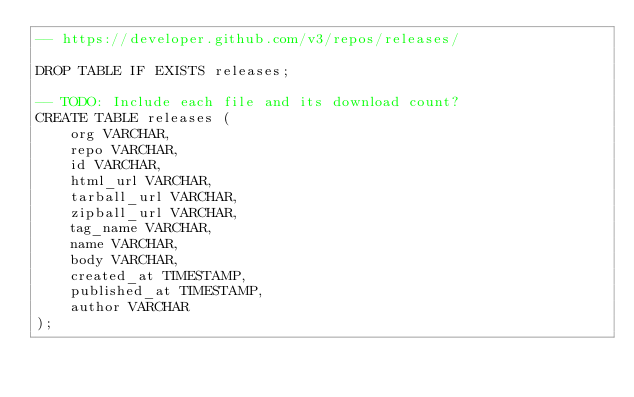Convert code to text. <code><loc_0><loc_0><loc_500><loc_500><_SQL_>-- https://developer.github.com/v3/repos/releases/

DROP TABLE IF EXISTS releases;

-- TODO: Include each file and its download count?
CREATE TABLE releases (
    org VARCHAR,
    repo VARCHAR,
    id VARCHAR,
    html_url VARCHAR,
    tarball_url VARCHAR,
    zipball_url VARCHAR,
    tag_name VARCHAR,
    name VARCHAR,
    body VARCHAR,
    created_at TIMESTAMP,
    published_at TIMESTAMP,
    author VARCHAR
);
</code> 